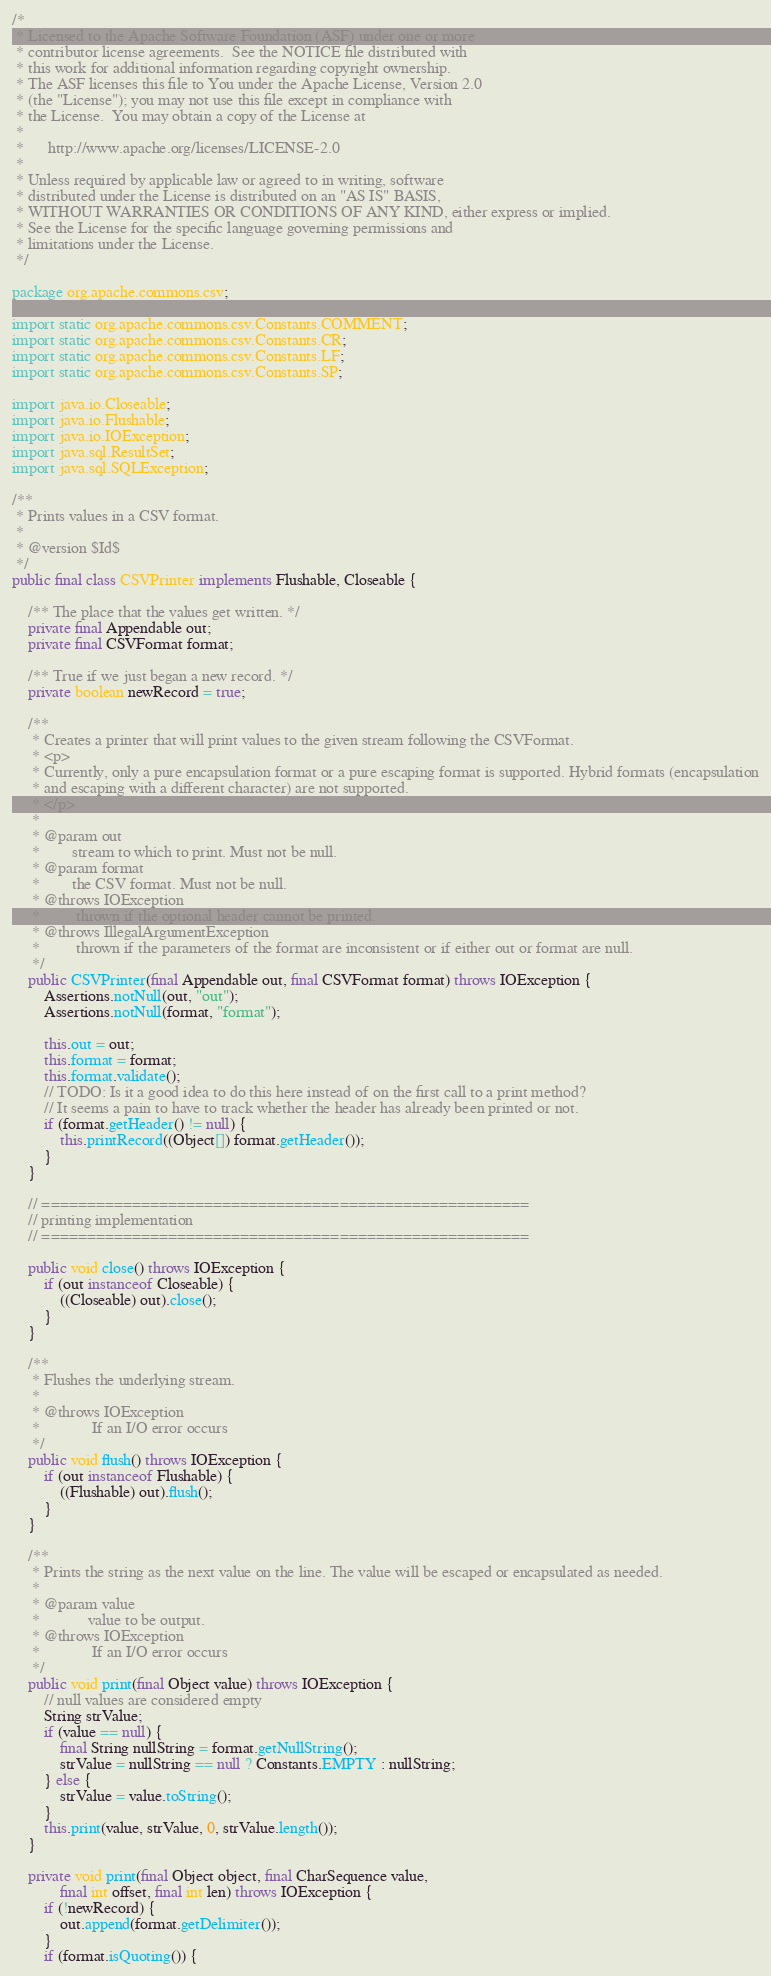<code> <loc_0><loc_0><loc_500><loc_500><_Java_>/*
 * Licensed to the Apache Software Foundation (ASF) under one or more
 * contributor license agreements.  See the NOTICE file distributed with
 * this work for additional information regarding copyright ownership.
 * The ASF licenses this file to You under the Apache License, Version 2.0
 * (the "License"); you may not use this file except in compliance with
 * the License.  You may obtain a copy of the License at
 *
 *      http://www.apache.org/licenses/LICENSE-2.0
 *
 * Unless required by applicable law or agreed to in writing, software
 * distributed under the License is distributed on an "AS IS" BASIS,
 * WITHOUT WARRANTIES OR CONDITIONS OF ANY KIND, either express or implied.
 * See the License for the specific language governing permissions and
 * limitations under the License.
 */

package org.apache.commons.csv;

import static org.apache.commons.csv.Constants.COMMENT;
import static org.apache.commons.csv.Constants.CR;
import static org.apache.commons.csv.Constants.LF;
import static org.apache.commons.csv.Constants.SP;

import java.io.Closeable;
import java.io.Flushable;
import java.io.IOException;
import java.sql.ResultSet;
import java.sql.SQLException;

/**
 * Prints values in a CSV format.
 *
 * @version $Id$
 */
public final class CSVPrinter implements Flushable, Closeable {

    /** The place that the values get written. */
    private final Appendable out;
    private final CSVFormat format;

    /** True if we just began a new record. */
    private boolean newRecord = true;

    /**
     * Creates a printer that will print values to the given stream following the CSVFormat.
     * <p>
     * Currently, only a pure encapsulation format or a pure escaping format is supported. Hybrid formats (encapsulation
     * and escaping with a different character) are not supported.
     * </p>
     * 
     * @param out
     *        stream to which to print. Must not be null.
     * @param format
     *        the CSV format. Must not be null.
     * @throws IOException
     *         thrown if the optional header cannot be printed.
     * @throws IllegalArgumentException
     *         thrown if the parameters of the format are inconsistent or if either out or format are null.
     */
    public CSVPrinter(final Appendable out, final CSVFormat format) throws IOException {
        Assertions.notNull(out, "out");
        Assertions.notNull(format, "format");

        this.out = out;
        this.format = format;
        this.format.validate();
        // TODO: Is it a good idea to do this here instead of on the first call to a print method?
        // It seems a pain to have to track whether the header has already been printed or not.
        if (format.getHeader() != null) {
            this.printRecord((Object[]) format.getHeader());
        }
    }

    // ======================================================
    // printing implementation
    // ======================================================

    public void close() throws IOException {
        if (out instanceof Closeable) {
            ((Closeable) out).close();
        }
    }

    /**
     * Flushes the underlying stream.
     *
     * @throws IOException
     *             If an I/O error occurs
     */
    public void flush() throws IOException {
        if (out instanceof Flushable) {
            ((Flushable) out).flush();
        }
    }

    /**
     * Prints the string as the next value on the line. The value will be escaped or encapsulated as needed.
     *
     * @param value
     *            value to be output.
     * @throws IOException
     *             If an I/O error occurs
     */
    public void print(final Object value) throws IOException {
        // null values are considered empty
        String strValue;
        if (value == null) {
            final String nullString = format.getNullString();
            strValue = nullString == null ? Constants.EMPTY : nullString;
        } else {
            strValue = value.toString();
        }
        this.print(value, strValue, 0, strValue.length());
    }

    private void print(final Object object, final CharSequence value,
            final int offset, final int len) throws IOException {
        if (!newRecord) {
            out.append(format.getDelimiter());
        }
        if (format.isQuoting()) {</code> 